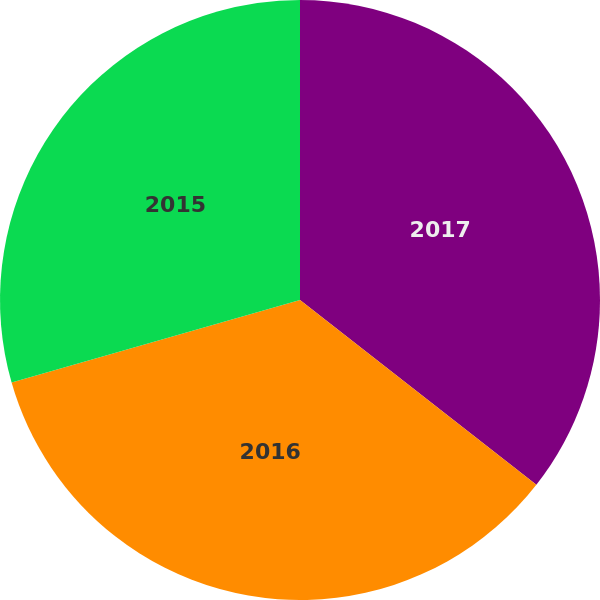Convert chart to OTSL. <chart><loc_0><loc_0><loc_500><loc_500><pie_chart><fcel>2017<fcel>2016<fcel>2015<nl><fcel>35.56%<fcel>35.0%<fcel>29.44%<nl></chart> 